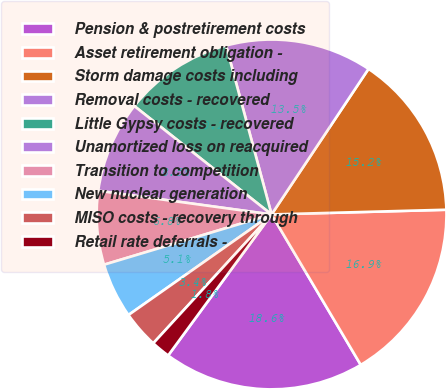Convert chart. <chart><loc_0><loc_0><loc_500><loc_500><pie_chart><fcel>Pension & postretirement costs<fcel>Asset retirement obligation -<fcel>Storm damage costs including<fcel>Removal costs - recovered<fcel>Little Gypsy costs - recovered<fcel>Unamortized loss on reacquired<fcel>Transition to competition<fcel>New nuclear generation<fcel>MISO costs - recovery through<fcel>Retail rate deferrals -<nl><fcel>18.59%<fcel>16.91%<fcel>15.22%<fcel>13.54%<fcel>10.17%<fcel>8.48%<fcel>6.8%<fcel>5.11%<fcel>3.43%<fcel>1.75%<nl></chart> 